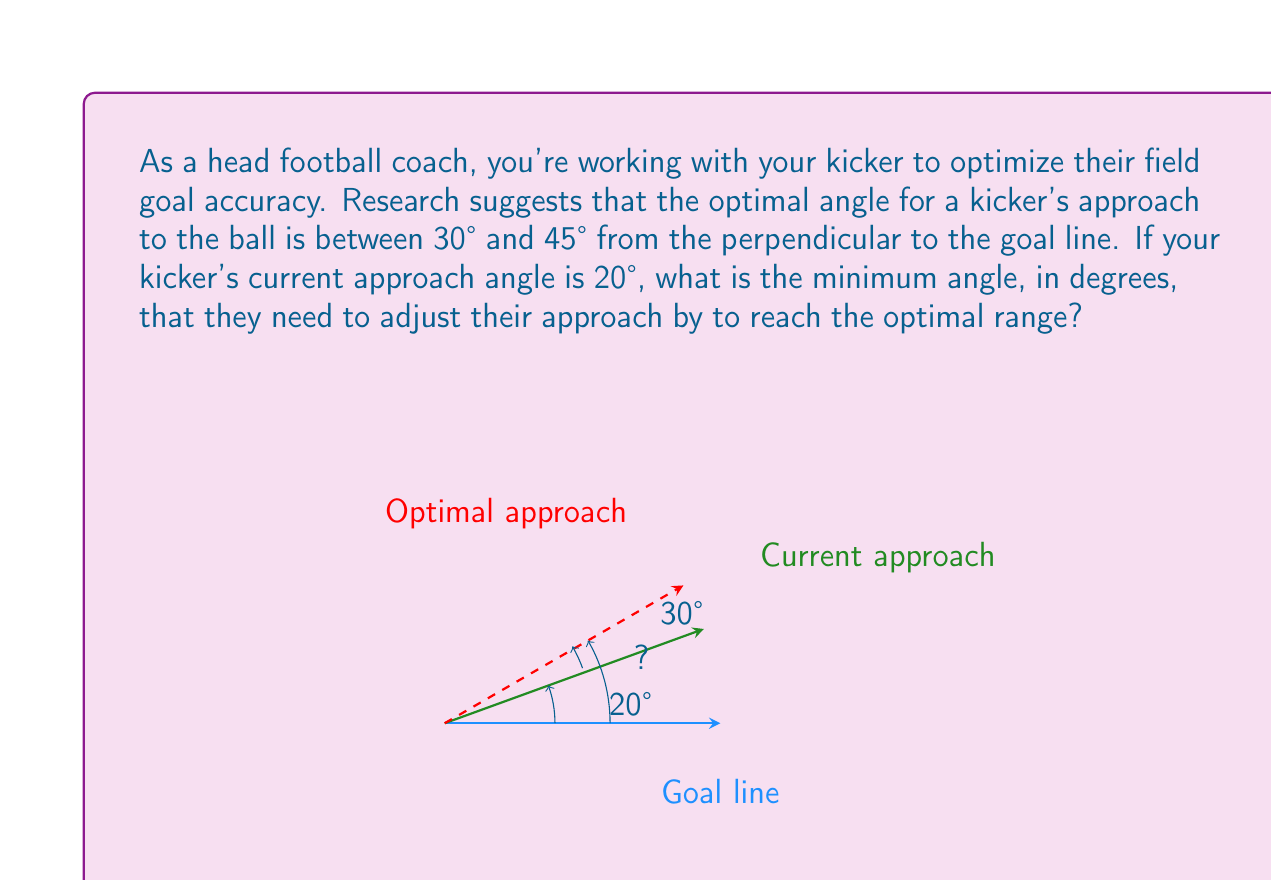Can you answer this question? To solve this problem, we need to find the difference between the lower bound of the optimal range and the current approach angle:

1. The lower bound of the optimal range is 30°.
2. The current approach angle is 20°.
3. The minimum adjustment needed is the difference between these two angles.

Let's calculate:

$$ \text{Minimum adjustment} = \text{Lower bound of optimal range} - \text{Current approach angle} $$
$$ \text{Minimum adjustment} = 30° - 20° = 10° $$

This means the kicker needs to increase their approach angle by at least 10° to reach the optimal range.

To verify:
$$ \text{New approach angle} = \text{Current approach angle} + \text{Minimum adjustment} $$
$$ \text{New approach angle} = 20° + 10° = 30° $$

The new approach angle of 30° is exactly at the lower bound of the optimal range (30° to 45°), confirming that our calculation is correct.
Answer: The minimum angle adjustment needed is 10°. 